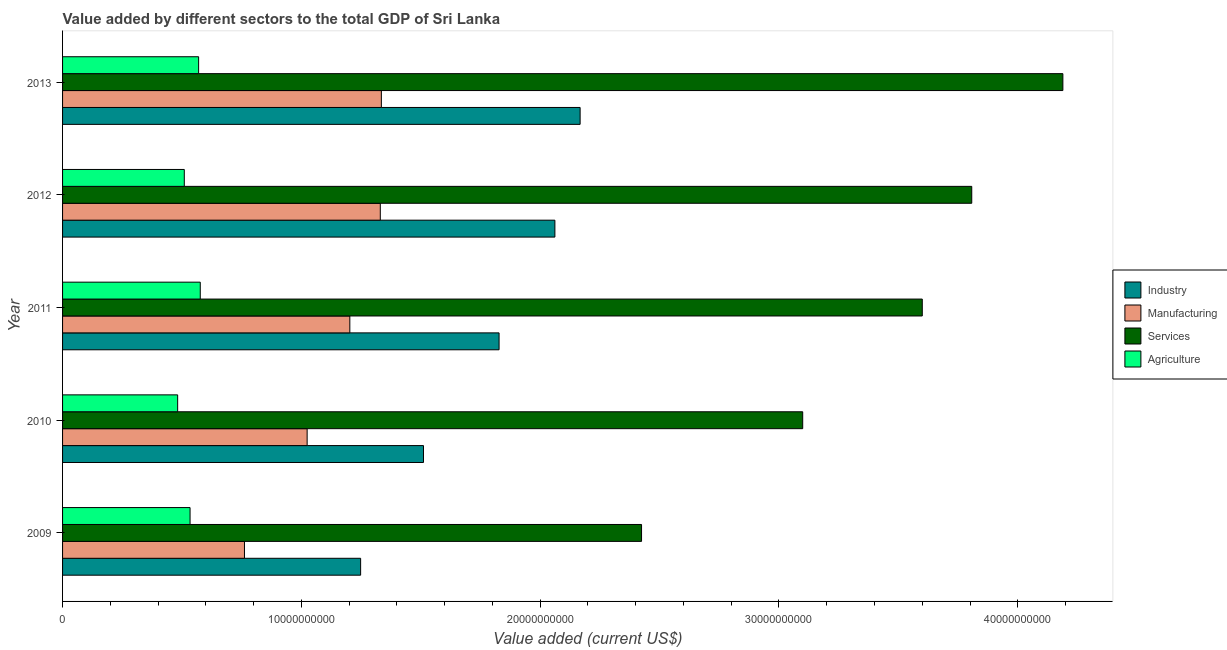How many different coloured bars are there?
Ensure brevity in your answer.  4. How many groups of bars are there?
Provide a succinct answer. 5. Are the number of bars per tick equal to the number of legend labels?
Provide a succinct answer. Yes. How many bars are there on the 5th tick from the top?
Give a very brief answer. 4. What is the label of the 5th group of bars from the top?
Offer a terse response. 2009. What is the value added by manufacturing sector in 2009?
Offer a very short reply. 7.62e+09. Across all years, what is the maximum value added by services sector?
Provide a short and direct response. 4.19e+1. Across all years, what is the minimum value added by industrial sector?
Make the answer very short. 1.25e+1. In which year was the value added by agricultural sector maximum?
Provide a short and direct response. 2011. What is the total value added by agricultural sector in the graph?
Ensure brevity in your answer.  2.67e+1. What is the difference between the value added by manufacturing sector in 2011 and that in 2012?
Give a very brief answer. -1.28e+09. What is the difference between the value added by industrial sector in 2009 and the value added by manufacturing sector in 2012?
Offer a terse response. -8.24e+08. What is the average value added by agricultural sector per year?
Provide a short and direct response. 5.34e+09. In the year 2009, what is the difference between the value added by manufacturing sector and value added by industrial sector?
Your answer should be compact. -4.86e+09. What is the ratio of the value added by manufacturing sector in 2011 to that in 2013?
Make the answer very short. 0.9. Is the value added by industrial sector in 2009 less than that in 2013?
Make the answer very short. Yes. Is the difference between the value added by industrial sector in 2009 and 2011 greater than the difference between the value added by services sector in 2009 and 2011?
Your answer should be compact. Yes. What is the difference between the highest and the second highest value added by agricultural sector?
Provide a short and direct response. 6.88e+07. What is the difference between the highest and the lowest value added by industrial sector?
Make the answer very short. 9.19e+09. In how many years, is the value added by industrial sector greater than the average value added by industrial sector taken over all years?
Offer a very short reply. 3. Is the sum of the value added by industrial sector in 2009 and 2010 greater than the maximum value added by agricultural sector across all years?
Ensure brevity in your answer.  Yes. Is it the case that in every year, the sum of the value added by industrial sector and value added by agricultural sector is greater than the sum of value added by manufacturing sector and value added by services sector?
Give a very brief answer. No. What does the 3rd bar from the top in 2013 represents?
Make the answer very short. Manufacturing. What does the 1st bar from the bottom in 2010 represents?
Give a very brief answer. Industry. Is it the case that in every year, the sum of the value added by industrial sector and value added by manufacturing sector is greater than the value added by services sector?
Your answer should be compact. No. Are all the bars in the graph horizontal?
Your answer should be compact. Yes. Does the graph contain grids?
Keep it short and to the point. No. How are the legend labels stacked?
Offer a terse response. Vertical. What is the title of the graph?
Give a very brief answer. Value added by different sectors to the total GDP of Sri Lanka. What is the label or title of the X-axis?
Keep it short and to the point. Value added (current US$). What is the label or title of the Y-axis?
Make the answer very short. Year. What is the Value added (current US$) in Industry in 2009?
Offer a very short reply. 1.25e+1. What is the Value added (current US$) of Manufacturing in 2009?
Your answer should be very brief. 7.62e+09. What is the Value added (current US$) of Services in 2009?
Offer a terse response. 2.42e+1. What is the Value added (current US$) of Agriculture in 2009?
Keep it short and to the point. 5.34e+09. What is the Value added (current US$) of Industry in 2010?
Make the answer very short. 1.51e+1. What is the Value added (current US$) in Manufacturing in 2010?
Your response must be concise. 1.02e+1. What is the Value added (current US$) of Services in 2010?
Ensure brevity in your answer.  3.10e+1. What is the Value added (current US$) of Agriculture in 2010?
Make the answer very short. 4.82e+09. What is the Value added (current US$) of Industry in 2011?
Your answer should be very brief. 1.83e+1. What is the Value added (current US$) in Manufacturing in 2011?
Provide a short and direct response. 1.20e+1. What is the Value added (current US$) in Services in 2011?
Give a very brief answer. 3.60e+1. What is the Value added (current US$) of Agriculture in 2011?
Keep it short and to the point. 5.77e+09. What is the Value added (current US$) of Industry in 2012?
Keep it short and to the point. 2.06e+1. What is the Value added (current US$) of Manufacturing in 2012?
Provide a succinct answer. 1.33e+1. What is the Value added (current US$) of Services in 2012?
Provide a succinct answer. 3.81e+1. What is the Value added (current US$) of Agriculture in 2012?
Keep it short and to the point. 5.10e+09. What is the Value added (current US$) of Industry in 2013?
Ensure brevity in your answer.  2.17e+1. What is the Value added (current US$) of Manufacturing in 2013?
Offer a terse response. 1.34e+1. What is the Value added (current US$) of Services in 2013?
Your answer should be compact. 4.19e+1. What is the Value added (current US$) of Agriculture in 2013?
Your answer should be very brief. 5.70e+09. Across all years, what is the maximum Value added (current US$) of Industry?
Offer a terse response. 2.17e+1. Across all years, what is the maximum Value added (current US$) in Manufacturing?
Provide a short and direct response. 1.34e+1. Across all years, what is the maximum Value added (current US$) in Services?
Your answer should be very brief. 4.19e+1. Across all years, what is the maximum Value added (current US$) of Agriculture?
Offer a very short reply. 5.77e+09. Across all years, what is the minimum Value added (current US$) in Industry?
Offer a terse response. 1.25e+1. Across all years, what is the minimum Value added (current US$) of Manufacturing?
Provide a short and direct response. 7.62e+09. Across all years, what is the minimum Value added (current US$) of Services?
Your answer should be compact. 2.42e+1. Across all years, what is the minimum Value added (current US$) in Agriculture?
Keep it short and to the point. 4.82e+09. What is the total Value added (current US$) in Industry in the graph?
Offer a terse response. 8.82e+1. What is the total Value added (current US$) of Manufacturing in the graph?
Keep it short and to the point. 5.65e+1. What is the total Value added (current US$) in Services in the graph?
Offer a very short reply. 1.71e+11. What is the total Value added (current US$) of Agriculture in the graph?
Make the answer very short. 2.67e+1. What is the difference between the Value added (current US$) in Industry in 2009 and that in 2010?
Your response must be concise. -2.63e+09. What is the difference between the Value added (current US$) of Manufacturing in 2009 and that in 2010?
Ensure brevity in your answer.  -2.62e+09. What is the difference between the Value added (current US$) in Services in 2009 and that in 2010?
Your answer should be very brief. -6.75e+09. What is the difference between the Value added (current US$) of Agriculture in 2009 and that in 2010?
Ensure brevity in your answer.  5.20e+08. What is the difference between the Value added (current US$) in Industry in 2009 and that in 2011?
Offer a very short reply. -5.80e+09. What is the difference between the Value added (current US$) of Manufacturing in 2009 and that in 2011?
Ensure brevity in your answer.  -4.41e+09. What is the difference between the Value added (current US$) of Services in 2009 and that in 2011?
Provide a short and direct response. -1.18e+1. What is the difference between the Value added (current US$) in Agriculture in 2009 and that in 2011?
Offer a terse response. -4.27e+08. What is the difference between the Value added (current US$) of Industry in 2009 and that in 2012?
Keep it short and to the point. -8.14e+09. What is the difference between the Value added (current US$) of Manufacturing in 2009 and that in 2012?
Give a very brief answer. -5.69e+09. What is the difference between the Value added (current US$) of Services in 2009 and that in 2012?
Your response must be concise. -1.38e+1. What is the difference between the Value added (current US$) in Agriculture in 2009 and that in 2012?
Your answer should be very brief. 2.41e+08. What is the difference between the Value added (current US$) in Industry in 2009 and that in 2013?
Ensure brevity in your answer.  -9.19e+09. What is the difference between the Value added (current US$) in Manufacturing in 2009 and that in 2013?
Your response must be concise. -5.73e+09. What is the difference between the Value added (current US$) in Services in 2009 and that in 2013?
Offer a very short reply. -1.76e+1. What is the difference between the Value added (current US$) in Agriculture in 2009 and that in 2013?
Your answer should be compact. -3.59e+08. What is the difference between the Value added (current US$) in Industry in 2010 and that in 2011?
Your response must be concise. -3.17e+09. What is the difference between the Value added (current US$) of Manufacturing in 2010 and that in 2011?
Make the answer very short. -1.79e+09. What is the difference between the Value added (current US$) in Services in 2010 and that in 2011?
Your answer should be compact. -5.01e+09. What is the difference between the Value added (current US$) of Agriculture in 2010 and that in 2011?
Your response must be concise. -9.47e+08. What is the difference between the Value added (current US$) in Industry in 2010 and that in 2012?
Your response must be concise. -5.50e+09. What is the difference between the Value added (current US$) in Manufacturing in 2010 and that in 2012?
Your answer should be compact. -3.06e+09. What is the difference between the Value added (current US$) of Services in 2010 and that in 2012?
Offer a very short reply. -7.08e+09. What is the difference between the Value added (current US$) of Agriculture in 2010 and that in 2012?
Keep it short and to the point. -2.78e+08. What is the difference between the Value added (current US$) in Industry in 2010 and that in 2013?
Ensure brevity in your answer.  -6.56e+09. What is the difference between the Value added (current US$) of Manufacturing in 2010 and that in 2013?
Keep it short and to the point. -3.11e+09. What is the difference between the Value added (current US$) of Services in 2010 and that in 2013?
Offer a very short reply. -1.09e+1. What is the difference between the Value added (current US$) in Agriculture in 2010 and that in 2013?
Provide a succinct answer. -8.78e+08. What is the difference between the Value added (current US$) of Industry in 2011 and that in 2012?
Your answer should be compact. -2.34e+09. What is the difference between the Value added (current US$) in Manufacturing in 2011 and that in 2012?
Provide a succinct answer. -1.28e+09. What is the difference between the Value added (current US$) of Services in 2011 and that in 2012?
Offer a terse response. -2.07e+09. What is the difference between the Value added (current US$) of Agriculture in 2011 and that in 2012?
Make the answer very short. 6.69e+08. What is the difference between the Value added (current US$) of Industry in 2011 and that in 2013?
Your response must be concise. -3.39e+09. What is the difference between the Value added (current US$) of Manufacturing in 2011 and that in 2013?
Provide a succinct answer. -1.32e+09. What is the difference between the Value added (current US$) in Services in 2011 and that in 2013?
Your answer should be compact. -5.89e+09. What is the difference between the Value added (current US$) in Agriculture in 2011 and that in 2013?
Offer a terse response. 6.88e+07. What is the difference between the Value added (current US$) in Industry in 2012 and that in 2013?
Your answer should be very brief. -1.06e+09. What is the difference between the Value added (current US$) of Manufacturing in 2012 and that in 2013?
Your answer should be compact. -4.47e+07. What is the difference between the Value added (current US$) in Services in 2012 and that in 2013?
Provide a short and direct response. -3.82e+09. What is the difference between the Value added (current US$) in Agriculture in 2012 and that in 2013?
Ensure brevity in your answer.  -6.00e+08. What is the difference between the Value added (current US$) of Industry in 2009 and the Value added (current US$) of Manufacturing in 2010?
Offer a very short reply. 2.24e+09. What is the difference between the Value added (current US$) of Industry in 2009 and the Value added (current US$) of Services in 2010?
Provide a short and direct response. -1.85e+1. What is the difference between the Value added (current US$) of Industry in 2009 and the Value added (current US$) of Agriculture in 2010?
Ensure brevity in your answer.  7.66e+09. What is the difference between the Value added (current US$) in Manufacturing in 2009 and the Value added (current US$) in Services in 2010?
Give a very brief answer. -2.34e+1. What is the difference between the Value added (current US$) of Manufacturing in 2009 and the Value added (current US$) of Agriculture in 2010?
Make the answer very short. 2.80e+09. What is the difference between the Value added (current US$) in Services in 2009 and the Value added (current US$) in Agriculture in 2010?
Offer a very short reply. 1.94e+1. What is the difference between the Value added (current US$) of Industry in 2009 and the Value added (current US$) of Manufacturing in 2011?
Ensure brevity in your answer.  4.52e+08. What is the difference between the Value added (current US$) of Industry in 2009 and the Value added (current US$) of Services in 2011?
Ensure brevity in your answer.  -2.35e+1. What is the difference between the Value added (current US$) of Industry in 2009 and the Value added (current US$) of Agriculture in 2011?
Give a very brief answer. 6.72e+09. What is the difference between the Value added (current US$) in Manufacturing in 2009 and the Value added (current US$) in Services in 2011?
Provide a succinct answer. -2.84e+1. What is the difference between the Value added (current US$) of Manufacturing in 2009 and the Value added (current US$) of Agriculture in 2011?
Provide a succinct answer. 1.85e+09. What is the difference between the Value added (current US$) of Services in 2009 and the Value added (current US$) of Agriculture in 2011?
Your answer should be very brief. 1.85e+1. What is the difference between the Value added (current US$) of Industry in 2009 and the Value added (current US$) of Manufacturing in 2012?
Provide a short and direct response. -8.24e+08. What is the difference between the Value added (current US$) of Industry in 2009 and the Value added (current US$) of Services in 2012?
Provide a succinct answer. -2.56e+1. What is the difference between the Value added (current US$) of Industry in 2009 and the Value added (current US$) of Agriculture in 2012?
Provide a succinct answer. 7.38e+09. What is the difference between the Value added (current US$) in Manufacturing in 2009 and the Value added (current US$) in Services in 2012?
Make the answer very short. -3.05e+1. What is the difference between the Value added (current US$) of Manufacturing in 2009 and the Value added (current US$) of Agriculture in 2012?
Keep it short and to the point. 2.52e+09. What is the difference between the Value added (current US$) in Services in 2009 and the Value added (current US$) in Agriculture in 2012?
Ensure brevity in your answer.  1.91e+1. What is the difference between the Value added (current US$) in Industry in 2009 and the Value added (current US$) in Manufacturing in 2013?
Make the answer very short. -8.69e+08. What is the difference between the Value added (current US$) of Industry in 2009 and the Value added (current US$) of Services in 2013?
Offer a very short reply. -2.94e+1. What is the difference between the Value added (current US$) of Industry in 2009 and the Value added (current US$) of Agriculture in 2013?
Offer a terse response. 6.78e+09. What is the difference between the Value added (current US$) in Manufacturing in 2009 and the Value added (current US$) in Services in 2013?
Your response must be concise. -3.43e+1. What is the difference between the Value added (current US$) of Manufacturing in 2009 and the Value added (current US$) of Agriculture in 2013?
Your answer should be very brief. 1.92e+09. What is the difference between the Value added (current US$) in Services in 2009 and the Value added (current US$) in Agriculture in 2013?
Your answer should be very brief. 1.85e+1. What is the difference between the Value added (current US$) of Industry in 2010 and the Value added (current US$) of Manufacturing in 2011?
Provide a short and direct response. 3.08e+09. What is the difference between the Value added (current US$) of Industry in 2010 and the Value added (current US$) of Services in 2011?
Offer a terse response. -2.09e+1. What is the difference between the Value added (current US$) in Industry in 2010 and the Value added (current US$) in Agriculture in 2011?
Your answer should be compact. 9.35e+09. What is the difference between the Value added (current US$) in Manufacturing in 2010 and the Value added (current US$) in Services in 2011?
Your response must be concise. -2.58e+1. What is the difference between the Value added (current US$) of Manufacturing in 2010 and the Value added (current US$) of Agriculture in 2011?
Keep it short and to the point. 4.48e+09. What is the difference between the Value added (current US$) of Services in 2010 and the Value added (current US$) of Agriculture in 2011?
Offer a terse response. 2.52e+1. What is the difference between the Value added (current US$) of Industry in 2010 and the Value added (current US$) of Manufacturing in 2012?
Offer a very short reply. 1.81e+09. What is the difference between the Value added (current US$) in Industry in 2010 and the Value added (current US$) in Services in 2012?
Ensure brevity in your answer.  -2.30e+1. What is the difference between the Value added (current US$) of Industry in 2010 and the Value added (current US$) of Agriculture in 2012?
Provide a short and direct response. 1.00e+1. What is the difference between the Value added (current US$) in Manufacturing in 2010 and the Value added (current US$) in Services in 2012?
Offer a terse response. -2.78e+1. What is the difference between the Value added (current US$) in Manufacturing in 2010 and the Value added (current US$) in Agriculture in 2012?
Ensure brevity in your answer.  5.14e+09. What is the difference between the Value added (current US$) in Services in 2010 and the Value added (current US$) in Agriculture in 2012?
Your answer should be compact. 2.59e+1. What is the difference between the Value added (current US$) in Industry in 2010 and the Value added (current US$) in Manufacturing in 2013?
Your answer should be compact. 1.76e+09. What is the difference between the Value added (current US$) of Industry in 2010 and the Value added (current US$) of Services in 2013?
Provide a succinct answer. -2.68e+1. What is the difference between the Value added (current US$) of Industry in 2010 and the Value added (current US$) of Agriculture in 2013?
Make the answer very short. 9.42e+09. What is the difference between the Value added (current US$) in Manufacturing in 2010 and the Value added (current US$) in Services in 2013?
Offer a very short reply. -3.16e+1. What is the difference between the Value added (current US$) of Manufacturing in 2010 and the Value added (current US$) of Agriculture in 2013?
Make the answer very short. 4.54e+09. What is the difference between the Value added (current US$) of Services in 2010 and the Value added (current US$) of Agriculture in 2013?
Make the answer very short. 2.53e+1. What is the difference between the Value added (current US$) in Industry in 2011 and the Value added (current US$) in Manufacturing in 2012?
Give a very brief answer. 4.97e+09. What is the difference between the Value added (current US$) in Industry in 2011 and the Value added (current US$) in Services in 2012?
Make the answer very short. -1.98e+1. What is the difference between the Value added (current US$) in Industry in 2011 and the Value added (current US$) in Agriculture in 2012?
Ensure brevity in your answer.  1.32e+1. What is the difference between the Value added (current US$) of Manufacturing in 2011 and the Value added (current US$) of Services in 2012?
Make the answer very short. -2.60e+1. What is the difference between the Value added (current US$) of Manufacturing in 2011 and the Value added (current US$) of Agriculture in 2012?
Make the answer very short. 6.93e+09. What is the difference between the Value added (current US$) of Services in 2011 and the Value added (current US$) of Agriculture in 2012?
Give a very brief answer. 3.09e+1. What is the difference between the Value added (current US$) of Industry in 2011 and the Value added (current US$) of Manufacturing in 2013?
Provide a short and direct response. 4.93e+09. What is the difference between the Value added (current US$) of Industry in 2011 and the Value added (current US$) of Services in 2013?
Your response must be concise. -2.36e+1. What is the difference between the Value added (current US$) in Industry in 2011 and the Value added (current US$) in Agriculture in 2013?
Offer a terse response. 1.26e+1. What is the difference between the Value added (current US$) in Manufacturing in 2011 and the Value added (current US$) in Services in 2013?
Offer a terse response. -2.99e+1. What is the difference between the Value added (current US$) in Manufacturing in 2011 and the Value added (current US$) in Agriculture in 2013?
Provide a succinct answer. 6.33e+09. What is the difference between the Value added (current US$) of Services in 2011 and the Value added (current US$) of Agriculture in 2013?
Ensure brevity in your answer.  3.03e+1. What is the difference between the Value added (current US$) of Industry in 2012 and the Value added (current US$) of Manufacturing in 2013?
Ensure brevity in your answer.  7.27e+09. What is the difference between the Value added (current US$) of Industry in 2012 and the Value added (current US$) of Services in 2013?
Your response must be concise. -2.13e+1. What is the difference between the Value added (current US$) of Industry in 2012 and the Value added (current US$) of Agriculture in 2013?
Offer a terse response. 1.49e+1. What is the difference between the Value added (current US$) of Manufacturing in 2012 and the Value added (current US$) of Services in 2013?
Your answer should be compact. -2.86e+1. What is the difference between the Value added (current US$) of Manufacturing in 2012 and the Value added (current US$) of Agriculture in 2013?
Give a very brief answer. 7.61e+09. What is the difference between the Value added (current US$) in Services in 2012 and the Value added (current US$) in Agriculture in 2013?
Your response must be concise. 3.24e+1. What is the average Value added (current US$) of Industry per year?
Your answer should be compact. 1.76e+1. What is the average Value added (current US$) in Manufacturing per year?
Give a very brief answer. 1.13e+1. What is the average Value added (current US$) of Services per year?
Give a very brief answer. 3.42e+1. What is the average Value added (current US$) of Agriculture per year?
Offer a very short reply. 5.34e+09. In the year 2009, what is the difference between the Value added (current US$) of Industry and Value added (current US$) of Manufacturing?
Give a very brief answer. 4.86e+09. In the year 2009, what is the difference between the Value added (current US$) in Industry and Value added (current US$) in Services?
Ensure brevity in your answer.  -1.18e+1. In the year 2009, what is the difference between the Value added (current US$) in Industry and Value added (current US$) in Agriculture?
Keep it short and to the point. 7.14e+09. In the year 2009, what is the difference between the Value added (current US$) of Manufacturing and Value added (current US$) of Services?
Offer a very short reply. -1.66e+1. In the year 2009, what is the difference between the Value added (current US$) of Manufacturing and Value added (current US$) of Agriculture?
Provide a short and direct response. 2.28e+09. In the year 2009, what is the difference between the Value added (current US$) of Services and Value added (current US$) of Agriculture?
Offer a very short reply. 1.89e+1. In the year 2010, what is the difference between the Value added (current US$) in Industry and Value added (current US$) in Manufacturing?
Ensure brevity in your answer.  4.87e+09. In the year 2010, what is the difference between the Value added (current US$) in Industry and Value added (current US$) in Services?
Make the answer very short. -1.59e+1. In the year 2010, what is the difference between the Value added (current US$) in Industry and Value added (current US$) in Agriculture?
Provide a succinct answer. 1.03e+1. In the year 2010, what is the difference between the Value added (current US$) in Manufacturing and Value added (current US$) in Services?
Keep it short and to the point. -2.08e+1. In the year 2010, what is the difference between the Value added (current US$) of Manufacturing and Value added (current US$) of Agriculture?
Ensure brevity in your answer.  5.42e+09. In the year 2010, what is the difference between the Value added (current US$) in Services and Value added (current US$) in Agriculture?
Make the answer very short. 2.62e+1. In the year 2011, what is the difference between the Value added (current US$) of Industry and Value added (current US$) of Manufacturing?
Keep it short and to the point. 6.25e+09. In the year 2011, what is the difference between the Value added (current US$) in Industry and Value added (current US$) in Services?
Your answer should be compact. -1.77e+1. In the year 2011, what is the difference between the Value added (current US$) in Industry and Value added (current US$) in Agriculture?
Give a very brief answer. 1.25e+1. In the year 2011, what is the difference between the Value added (current US$) of Manufacturing and Value added (current US$) of Services?
Offer a terse response. -2.40e+1. In the year 2011, what is the difference between the Value added (current US$) in Manufacturing and Value added (current US$) in Agriculture?
Keep it short and to the point. 6.26e+09. In the year 2011, what is the difference between the Value added (current US$) in Services and Value added (current US$) in Agriculture?
Your response must be concise. 3.02e+1. In the year 2012, what is the difference between the Value added (current US$) of Industry and Value added (current US$) of Manufacturing?
Offer a terse response. 7.31e+09. In the year 2012, what is the difference between the Value added (current US$) of Industry and Value added (current US$) of Services?
Ensure brevity in your answer.  -1.75e+1. In the year 2012, what is the difference between the Value added (current US$) of Industry and Value added (current US$) of Agriculture?
Give a very brief answer. 1.55e+1. In the year 2012, what is the difference between the Value added (current US$) in Manufacturing and Value added (current US$) in Services?
Provide a succinct answer. -2.48e+1. In the year 2012, what is the difference between the Value added (current US$) in Manufacturing and Value added (current US$) in Agriculture?
Offer a terse response. 8.21e+09. In the year 2012, what is the difference between the Value added (current US$) in Services and Value added (current US$) in Agriculture?
Make the answer very short. 3.30e+1. In the year 2013, what is the difference between the Value added (current US$) of Industry and Value added (current US$) of Manufacturing?
Your response must be concise. 8.32e+09. In the year 2013, what is the difference between the Value added (current US$) of Industry and Value added (current US$) of Services?
Your answer should be very brief. -2.02e+1. In the year 2013, what is the difference between the Value added (current US$) in Industry and Value added (current US$) in Agriculture?
Make the answer very short. 1.60e+1. In the year 2013, what is the difference between the Value added (current US$) in Manufacturing and Value added (current US$) in Services?
Your response must be concise. -2.85e+1. In the year 2013, what is the difference between the Value added (current US$) of Manufacturing and Value added (current US$) of Agriculture?
Ensure brevity in your answer.  7.65e+09. In the year 2013, what is the difference between the Value added (current US$) in Services and Value added (current US$) in Agriculture?
Provide a succinct answer. 3.62e+1. What is the ratio of the Value added (current US$) in Industry in 2009 to that in 2010?
Provide a succinct answer. 0.83. What is the ratio of the Value added (current US$) in Manufacturing in 2009 to that in 2010?
Offer a terse response. 0.74. What is the ratio of the Value added (current US$) in Services in 2009 to that in 2010?
Provide a short and direct response. 0.78. What is the ratio of the Value added (current US$) in Agriculture in 2009 to that in 2010?
Your answer should be compact. 1.11. What is the ratio of the Value added (current US$) in Industry in 2009 to that in 2011?
Provide a succinct answer. 0.68. What is the ratio of the Value added (current US$) of Manufacturing in 2009 to that in 2011?
Your response must be concise. 0.63. What is the ratio of the Value added (current US$) in Services in 2009 to that in 2011?
Provide a short and direct response. 0.67. What is the ratio of the Value added (current US$) of Agriculture in 2009 to that in 2011?
Offer a terse response. 0.93. What is the ratio of the Value added (current US$) of Industry in 2009 to that in 2012?
Your answer should be very brief. 0.61. What is the ratio of the Value added (current US$) of Manufacturing in 2009 to that in 2012?
Offer a very short reply. 0.57. What is the ratio of the Value added (current US$) of Services in 2009 to that in 2012?
Offer a very short reply. 0.64. What is the ratio of the Value added (current US$) of Agriculture in 2009 to that in 2012?
Keep it short and to the point. 1.05. What is the ratio of the Value added (current US$) in Industry in 2009 to that in 2013?
Offer a very short reply. 0.58. What is the ratio of the Value added (current US$) of Manufacturing in 2009 to that in 2013?
Offer a terse response. 0.57. What is the ratio of the Value added (current US$) of Services in 2009 to that in 2013?
Keep it short and to the point. 0.58. What is the ratio of the Value added (current US$) of Agriculture in 2009 to that in 2013?
Keep it short and to the point. 0.94. What is the ratio of the Value added (current US$) in Industry in 2010 to that in 2011?
Offer a very short reply. 0.83. What is the ratio of the Value added (current US$) of Manufacturing in 2010 to that in 2011?
Ensure brevity in your answer.  0.85. What is the ratio of the Value added (current US$) of Services in 2010 to that in 2011?
Give a very brief answer. 0.86. What is the ratio of the Value added (current US$) of Agriculture in 2010 to that in 2011?
Provide a succinct answer. 0.84. What is the ratio of the Value added (current US$) in Industry in 2010 to that in 2012?
Offer a very short reply. 0.73. What is the ratio of the Value added (current US$) of Manufacturing in 2010 to that in 2012?
Your answer should be very brief. 0.77. What is the ratio of the Value added (current US$) in Services in 2010 to that in 2012?
Your answer should be compact. 0.81. What is the ratio of the Value added (current US$) of Agriculture in 2010 to that in 2012?
Your answer should be compact. 0.95. What is the ratio of the Value added (current US$) in Industry in 2010 to that in 2013?
Give a very brief answer. 0.7. What is the ratio of the Value added (current US$) of Manufacturing in 2010 to that in 2013?
Your response must be concise. 0.77. What is the ratio of the Value added (current US$) of Services in 2010 to that in 2013?
Offer a very short reply. 0.74. What is the ratio of the Value added (current US$) in Agriculture in 2010 to that in 2013?
Your answer should be compact. 0.85. What is the ratio of the Value added (current US$) in Industry in 2011 to that in 2012?
Your answer should be very brief. 0.89. What is the ratio of the Value added (current US$) in Manufacturing in 2011 to that in 2012?
Keep it short and to the point. 0.9. What is the ratio of the Value added (current US$) of Services in 2011 to that in 2012?
Ensure brevity in your answer.  0.95. What is the ratio of the Value added (current US$) in Agriculture in 2011 to that in 2012?
Provide a succinct answer. 1.13. What is the ratio of the Value added (current US$) of Industry in 2011 to that in 2013?
Your answer should be compact. 0.84. What is the ratio of the Value added (current US$) in Manufacturing in 2011 to that in 2013?
Provide a succinct answer. 0.9. What is the ratio of the Value added (current US$) of Services in 2011 to that in 2013?
Keep it short and to the point. 0.86. What is the ratio of the Value added (current US$) in Agriculture in 2011 to that in 2013?
Offer a terse response. 1.01. What is the ratio of the Value added (current US$) in Industry in 2012 to that in 2013?
Your answer should be very brief. 0.95. What is the ratio of the Value added (current US$) of Manufacturing in 2012 to that in 2013?
Your response must be concise. 1. What is the ratio of the Value added (current US$) of Services in 2012 to that in 2013?
Keep it short and to the point. 0.91. What is the ratio of the Value added (current US$) of Agriculture in 2012 to that in 2013?
Ensure brevity in your answer.  0.89. What is the difference between the highest and the second highest Value added (current US$) of Industry?
Give a very brief answer. 1.06e+09. What is the difference between the highest and the second highest Value added (current US$) in Manufacturing?
Your answer should be very brief. 4.47e+07. What is the difference between the highest and the second highest Value added (current US$) of Services?
Keep it short and to the point. 3.82e+09. What is the difference between the highest and the second highest Value added (current US$) of Agriculture?
Your answer should be very brief. 6.88e+07. What is the difference between the highest and the lowest Value added (current US$) of Industry?
Provide a short and direct response. 9.19e+09. What is the difference between the highest and the lowest Value added (current US$) in Manufacturing?
Offer a very short reply. 5.73e+09. What is the difference between the highest and the lowest Value added (current US$) in Services?
Your response must be concise. 1.76e+1. What is the difference between the highest and the lowest Value added (current US$) of Agriculture?
Provide a short and direct response. 9.47e+08. 